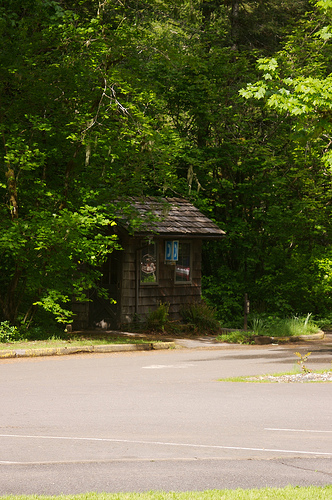<image>
Can you confirm if the house is behind the tree? No. The house is not behind the tree. From this viewpoint, the house appears to be positioned elsewhere in the scene. 